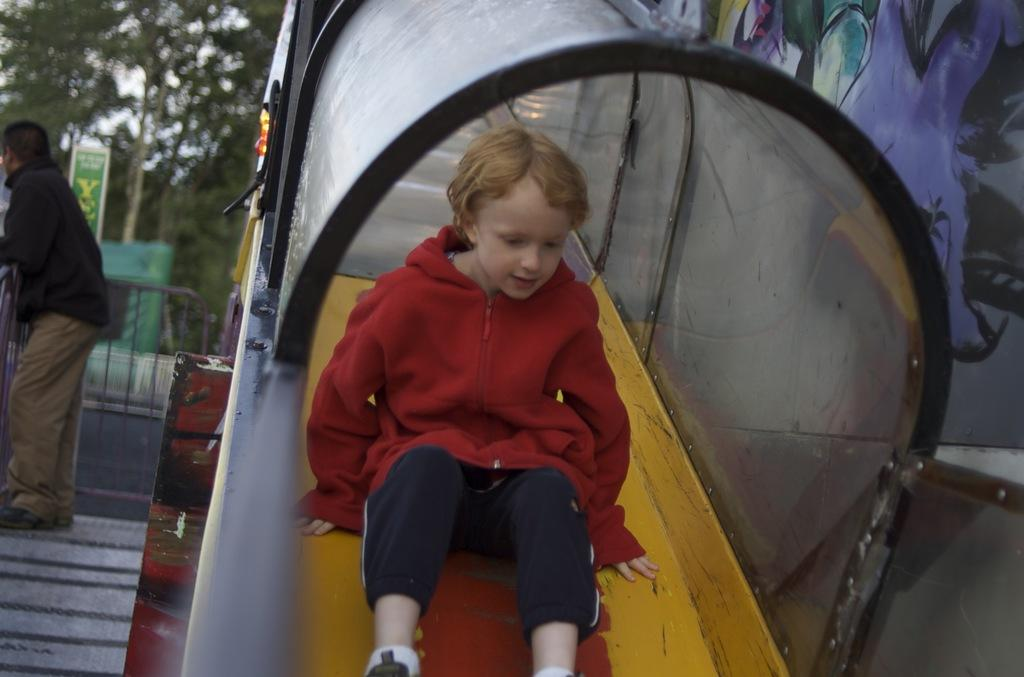What is the boy doing in the image? The boy is sliding down from a slider in the image. Can you describe the slider's location? The slider appears to be in a tunnel in the image. Who else is present in the image? There is a person standing nearby in the image. What can be seen in the background of the image? Trees are visible in the background of the image. What type of structure is present in the image? There is a board-like structure in the image. How many gold coins can be seen falling from the sky in the image? There are no gold coins or any falling objects visible in the image. 